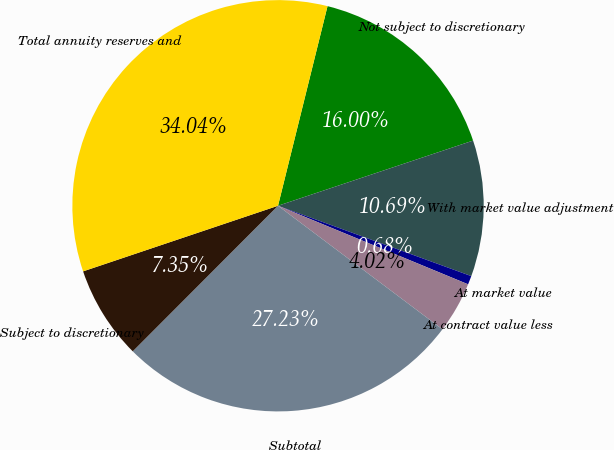<chart> <loc_0><loc_0><loc_500><loc_500><pie_chart><fcel>Not subject to discretionary<fcel>With market value adjustment<fcel>At market value<fcel>At contract value less<fcel>Subtotal<fcel>Subject to discretionary<fcel>Total annuity reserves and<nl><fcel>16.0%<fcel>10.69%<fcel>0.68%<fcel>4.02%<fcel>27.23%<fcel>7.35%<fcel>34.04%<nl></chart> 